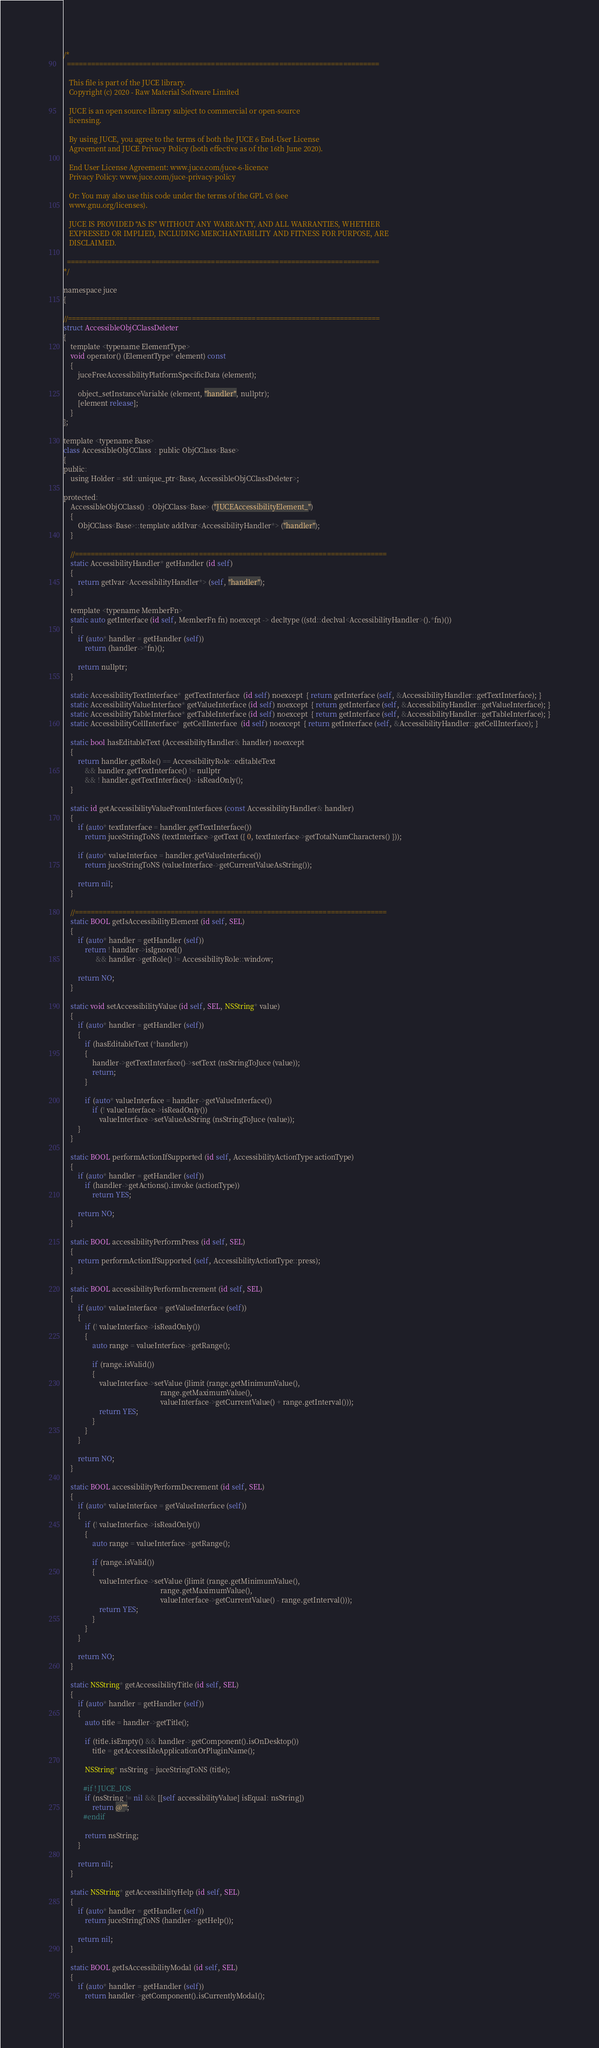<code> <loc_0><loc_0><loc_500><loc_500><_ObjectiveC_>/*
  ==============================================================================

   This file is part of the JUCE library.
   Copyright (c) 2020 - Raw Material Software Limited

   JUCE is an open source library subject to commercial or open-source
   licensing.

   By using JUCE, you agree to the terms of both the JUCE 6 End-User License
   Agreement and JUCE Privacy Policy (both effective as of the 16th June 2020).

   End User License Agreement: www.juce.com/juce-6-licence
   Privacy Policy: www.juce.com/juce-privacy-policy

   Or: You may also use this code under the terms of the GPL v3 (see
   www.gnu.org/licenses).

   JUCE IS PROVIDED "AS IS" WITHOUT ANY WARRANTY, AND ALL WARRANTIES, WHETHER
   EXPRESSED OR IMPLIED, INCLUDING MERCHANTABILITY AND FITNESS FOR PURPOSE, ARE
   DISCLAIMED.

  ==============================================================================
*/

namespace juce
{

//==============================================================================
struct AccessibleObjCClassDeleter
{
    template <typename ElementType>
    void operator() (ElementType* element) const
    {
        juceFreeAccessibilityPlatformSpecificData (element);

        object_setInstanceVariable (element, "handler", nullptr);
        [element release];
    }
};

template <typename Base>
class AccessibleObjCClass  : public ObjCClass<Base>
{
public:
    using Holder = std::unique_ptr<Base, AccessibleObjCClassDeleter>;

protected:
    AccessibleObjCClass()  : ObjCClass<Base> ("JUCEAccessibilityElement_")
    {
        ObjCClass<Base>::template addIvar<AccessibilityHandler*> ("handler");
    }

    //==============================================================================
    static AccessibilityHandler* getHandler (id self)
    {
        return getIvar<AccessibilityHandler*> (self, "handler");
    }

    template <typename MemberFn>
    static auto getInterface (id self, MemberFn fn) noexcept -> decltype ((std::declval<AccessibilityHandler>().*fn)())
    {
        if (auto* handler = getHandler (self))
            return (handler->*fn)();

        return nullptr;
    }

    static AccessibilityTextInterface*  getTextInterface  (id self) noexcept  { return getInterface (self, &AccessibilityHandler::getTextInterface); }
    static AccessibilityValueInterface* getValueInterface (id self) noexcept  { return getInterface (self, &AccessibilityHandler::getValueInterface); }
    static AccessibilityTableInterface* getTableInterface (id self) noexcept  { return getInterface (self, &AccessibilityHandler::getTableInterface); }
    static AccessibilityCellInterface*  getCellInterface  (id self) noexcept  { return getInterface (self, &AccessibilityHandler::getCellInterface); }

    static bool hasEditableText (AccessibilityHandler& handler) noexcept
    {
        return handler.getRole() == AccessibilityRole::editableText
            && handler.getTextInterface() != nullptr
            && ! handler.getTextInterface()->isReadOnly();
    }

    static id getAccessibilityValueFromInterfaces (const AccessibilityHandler& handler)
    {
        if (auto* textInterface = handler.getTextInterface())
            return juceStringToNS (textInterface->getText ({ 0, textInterface->getTotalNumCharacters() }));

        if (auto* valueInterface = handler.getValueInterface())
            return juceStringToNS (valueInterface->getCurrentValueAsString());

        return nil;
    }

    //==============================================================================
    static BOOL getIsAccessibilityElement (id self, SEL)
    {
        if (auto* handler = getHandler (self))
            return ! handler->isIgnored()
                  && handler->getRole() != AccessibilityRole::window;

        return NO;
    }

    static void setAccessibilityValue (id self, SEL, NSString* value)
    {
        if (auto* handler = getHandler (self))
        {
            if (hasEditableText (*handler))
            {
                handler->getTextInterface()->setText (nsStringToJuce (value));
                return;
            }

            if (auto* valueInterface = handler->getValueInterface())
                if (! valueInterface->isReadOnly())
                    valueInterface->setValueAsString (nsStringToJuce (value));
        }
    }

    static BOOL performActionIfSupported (id self, AccessibilityActionType actionType)
    {
        if (auto* handler = getHandler (self))
            if (handler->getActions().invoke (actionType))
                return YES;

        return NO;
    }

    static BOOL accessibilityPerformPress (id self, SEL)
    {
        return performActionIfSupported (self, AccessibilityActionType::press);
    }

    static BOOL accessibilityPerformIncrement (id self, SEL)
    {
        if (auto* valueInterface = getValueInterface (self))
        {
            if (! valueInterface->isReadOnly())
            {
                auto range = valueInterface->getRange();

                if (range.isValid())
                {
                    valueInterface->setValue (jlimit (range.getMinimumValue(),
                                                      range.getMaximumValue(),
                                                      valueInterface->getCurrentValue() + range.getInterval()));
                    return YES;
                }
            }
        }

        return NO;
    }

    static BOOL accessibilityPerformDecrement (id self, SEL)
    {
        if (auto* valueInterface = getValueInterface (self))
        {
            if (! valueInterface->isReadOnly())
            {
                auto range = valueInterface->getRange();

                if (range.isValid())
                {
                    valueInterface->setValue (jlimit (range.getMinimumValue(),
                                                      range.getMaximumValue(),
                                                      valueInterface->getCurrentValue() - range.getInterval()));
                    return YES;
                }
            }
        }

        return NO;
    }

    static NSString* getAccessibilityTitle (id self, SEL)
    {
        if (auto* handler = getHandler (self))
        {
            auto title = handler->getTitle();

            if (title.isEmpty() && handler->getComponent().isOnDesktop())
                title = getAccessibleApplicationOrPluginName();

            NSString* nsString = juceStringToNS (title);

           #if ! JUCE_IOS
            if (nsString != nil && [[self accessibilityValue] isEqual: nsString])
                return @"";
           #endif

            return nsString;
        }

        return nil;
    }

    static NSString* getAccessibilityHelp (id self, SEL)
    {
        if (auto* handler = getHandler (self))
            return juceStringToNS (handler->getHelp());

        return nil;
    }

    static BOOL getIsAccessibilityModal (id self, SEL)
    {
        if (auto* handler = getHandler (self))
            return handler->getComponent().isCurrentlyModal();
</code> 